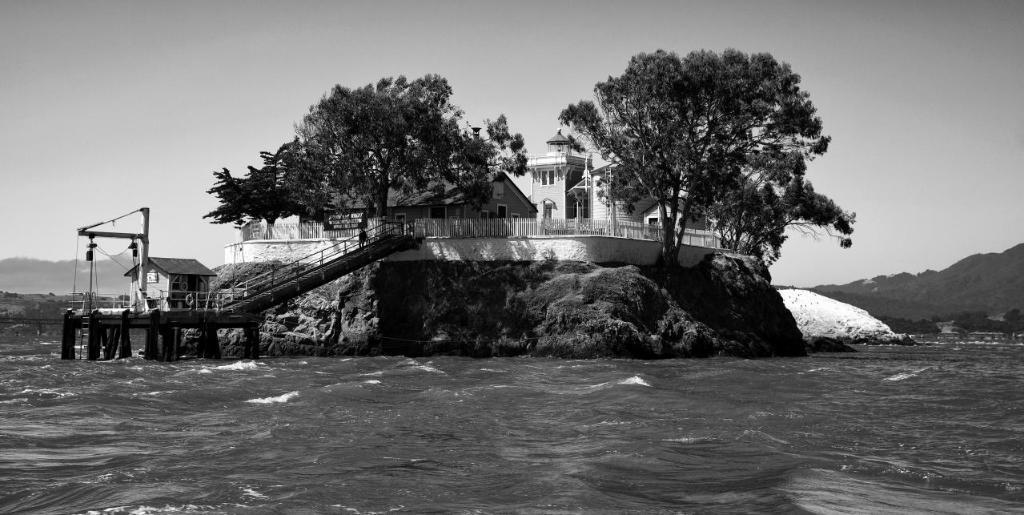How would you summarize this image in a sentence or two? This is a black and white image. In this image there is water. Also there is a rock. On the rock there is a building with windows. Also there are trees and railings. And there is a steps with railings attached to the building with a deck. There is a small house on the deck. In the background there is sky. 